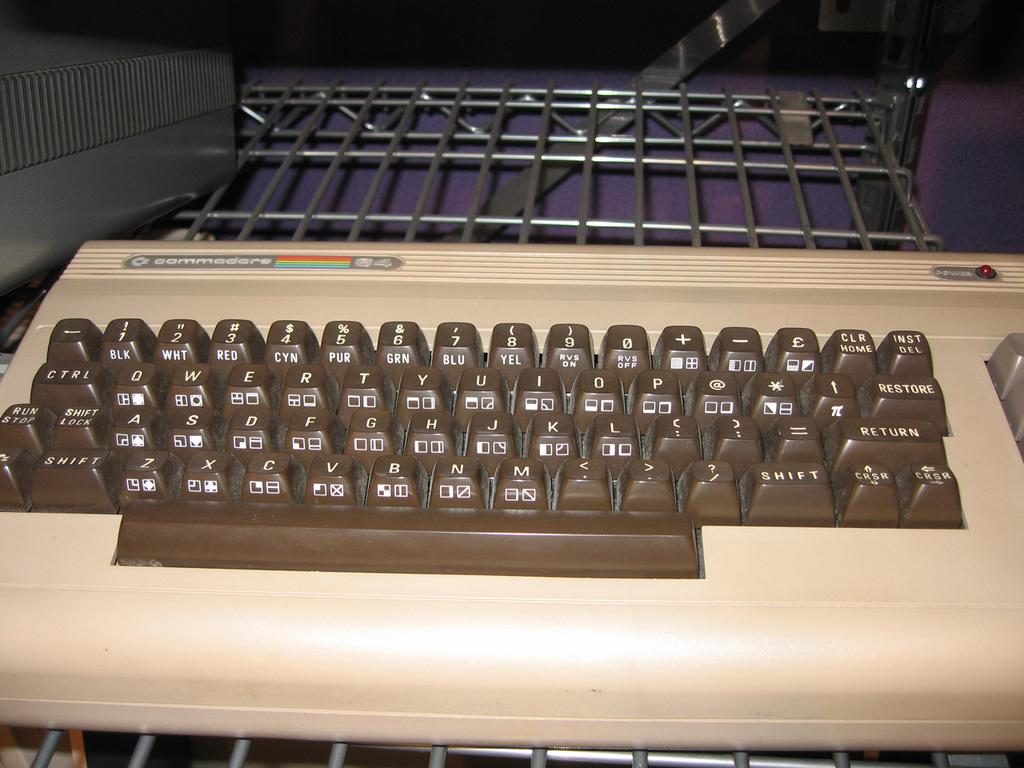<image>
Create a compact narrative representing the image presented. An old commodore typewriter in front of a wire rack. 